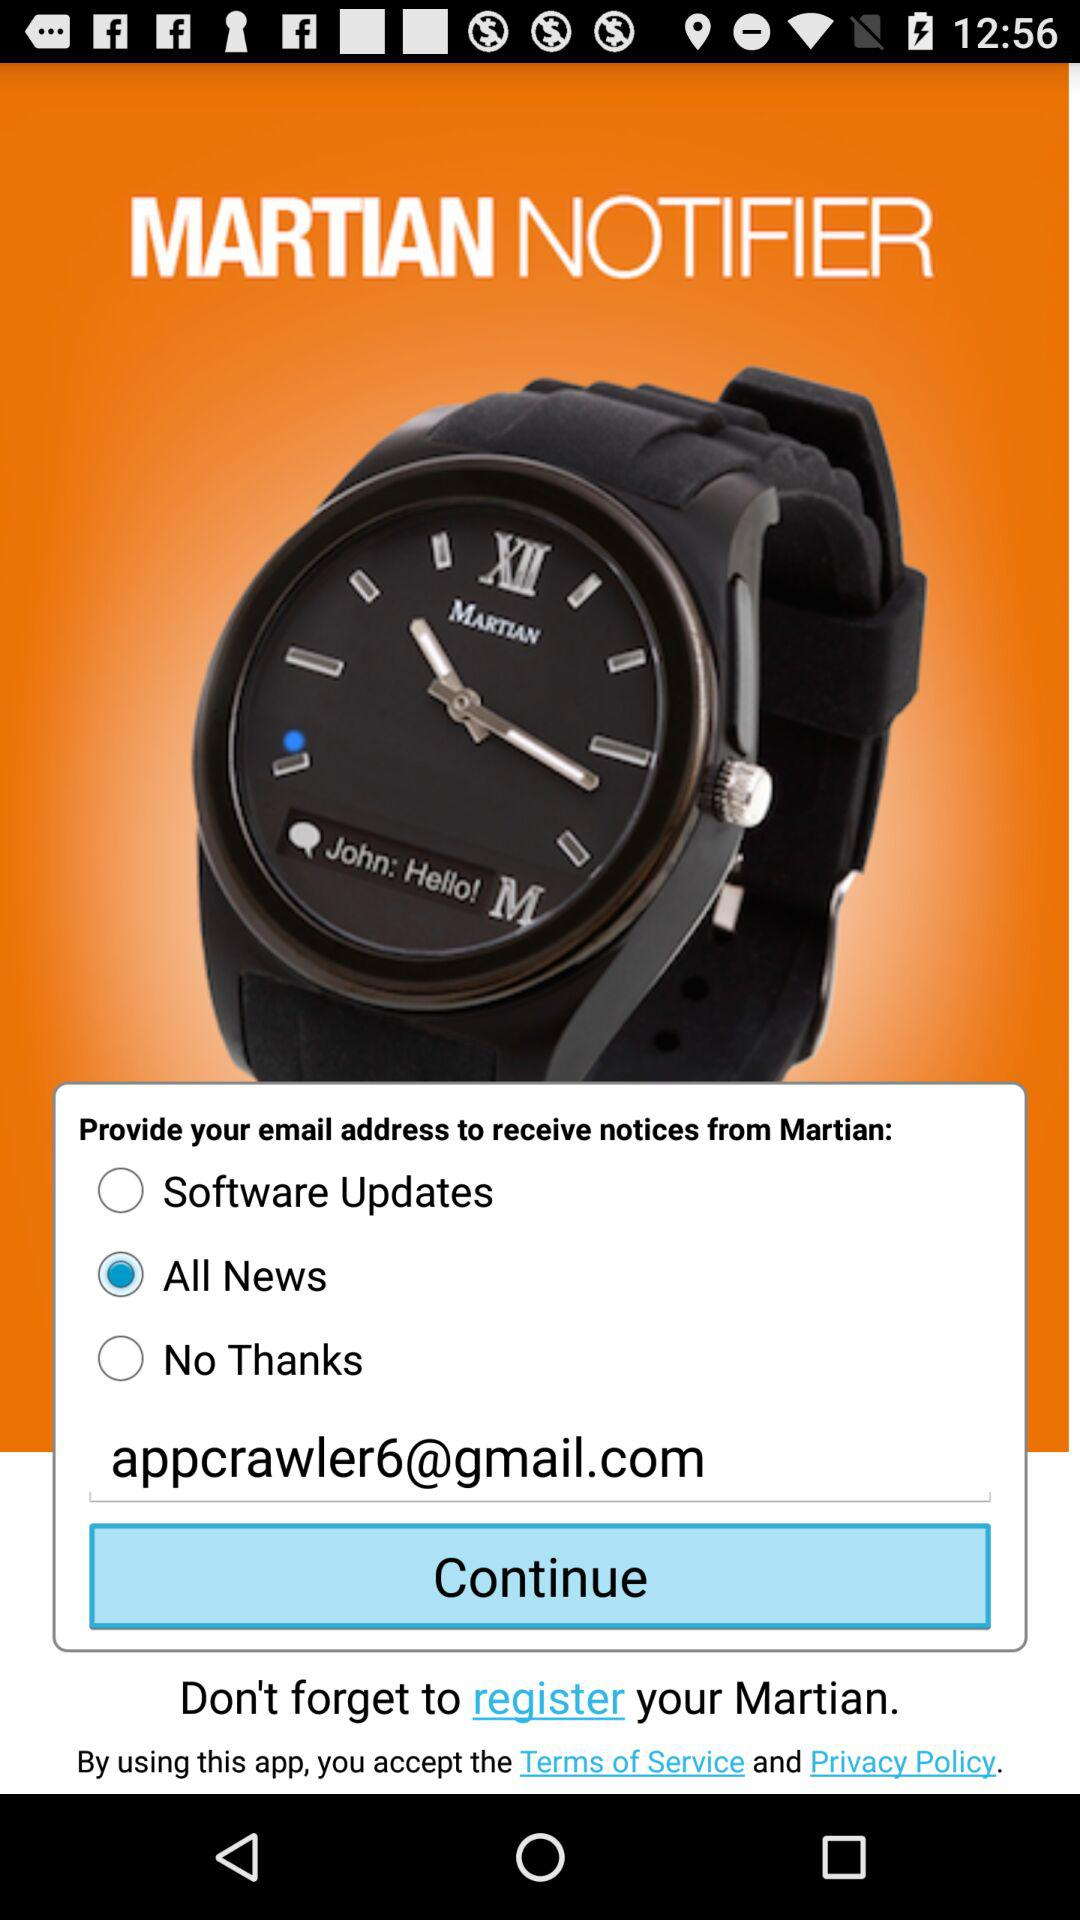What is the email address? The email address is appcrawler6@gmail.com. 